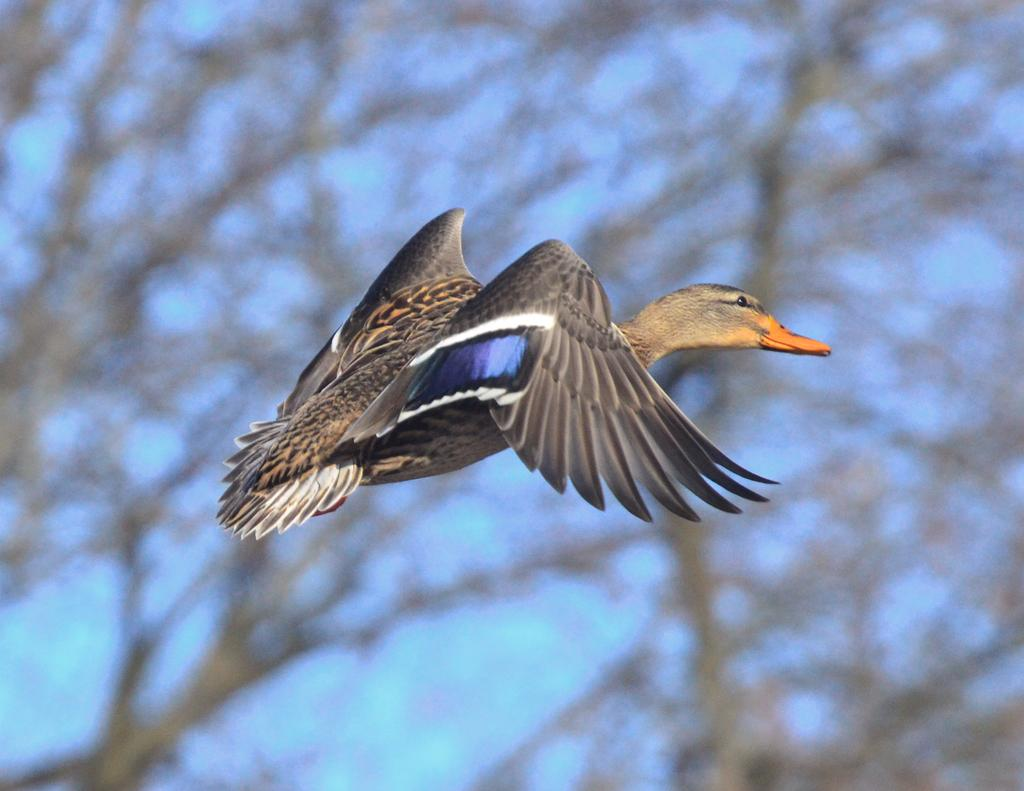What type of animal can be seen in the image? There is a bird in the image. What is the bird doing in the image? The bird is flying. What can be seen in the background of the image? There are trees and a blue sky in the background of the image. How many grandfathers are present in the image? There are no grandfathers present in the image; it features a bird flying in front of trees and a blue sky. What type of bulb can be seen illuminating the bird in the image? There is no bulb present in the image; it is a bird flying in front of trees and a blue sky. 